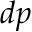<formula> <loc_0><loc_0><loc_500><loc_500>d p</formula> 